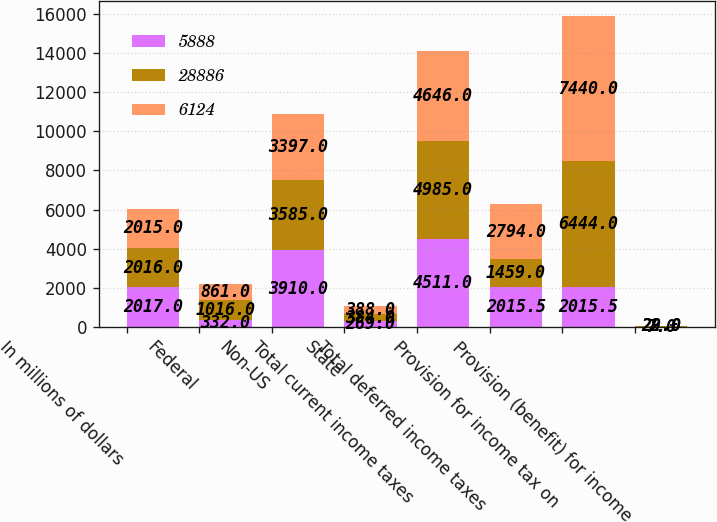Convert chart. <chart><loc_0><loc_0><loc_500><loc_500><stacked_bar_chart><ecel><fcel>In millions of dollars<fcel>Federal<fcel>Non-US<fcel>State<fcel>Total current income taxes<fcel>Total deferred income taxes<fcel>Provision for income tax on<fcel>Provision (benefit) for income<nl><fcel>5888<fcel>2017<fcel>332<fcel>3910<fcel>269<fcel>4511<fcel>2015.5<fcel>2015.5<fcel>7<nl><fcel>28886<fcel>2016<fcel>1016<fcel>3585<fcel>384<fcel>4985<fcel>1459<fcel>6444<fcel>22<nl><fcel>6124<fcel>2015<fcel>861<fcel>3397<fcel>388<fcel>4646<fcel>2794<fcel>7440<fcel>29<nl></chart> 